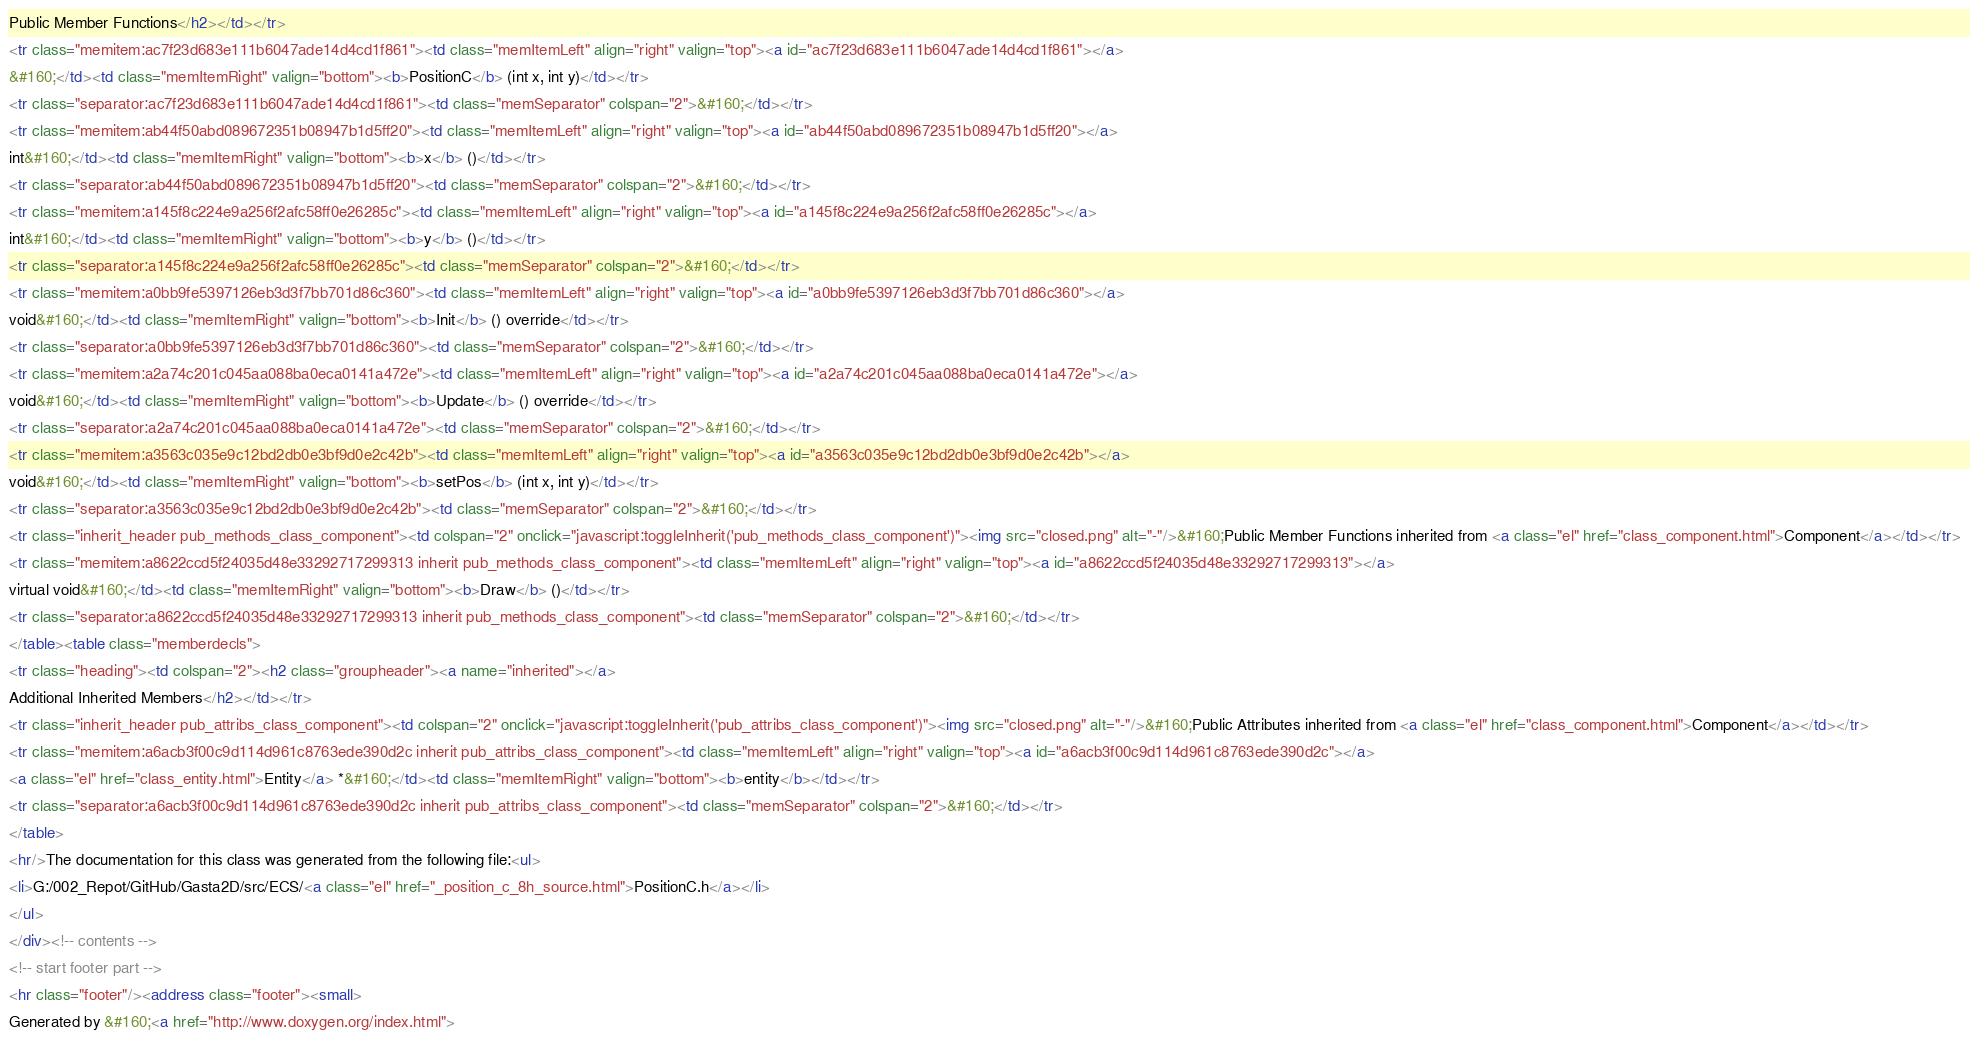Convert code to text. <code><loc_0><loc_0><loc_500><loc_500><_HTML_>Public Member Functions</h2></td></tr>
<tr class="memitem:ac7f23d683e111b6047ade14d4cd1f861"><td class="memItemLeft" align="right" valign="top"><a id="ac7f23d683e111b6047ade14d4cd1f861"></a>
&#160;</td><td class="memItemRight" valign="bottom"><b>PositionC</b> (int x, int y)</td></tr>
<tr class="separator:ac7f23d683e111b6047ade14d4cd1f861"><td class="memSeparator" colspan="2">&#160;</td></tr>
<tr class="memitem:ab44f50abd089672351b08947b1d5ff20"><td class="memItemLeft" align="right" valign="top"><a id="ab44f50abd089672351b08947b1d5ff20"></a>
int&#160;</td><td class="memItemRight" valign="bottom"><b>x</b> ()</td></tr>
<tr class="separator:ab44f50abd089672351b08947b1d5ff20"><td class="memSeparator" colspan="2">&#160;</td></tr>
<tr class="memitem:a145f8c224e9a256f2afc58ff0e26285c"><td class="memItemLeft" align="right" valign="top"><a id="a145f8c224e9a256f2afc58ff0e26285c"></a>
int&#160;</td><td class="memItemRight" valign="bottom"><b>y</b> ()</td></tr>
<tr class="separator:a145f8c224e9a256f2afc58ff0e26285c"><td class="memSeparator" colspan="2">&#160;</td></tr>
<tr class="memitem:a0bb9fe5397126eb3d3f7bb701d86c360"><td class="memItemLeft" align="right" valign="top"><a id="a0bb9fe5397126eb3d3f7bb701d86c360"></a>
void&#160;</td><td class="memItemRight" valign="bottom"><b>Init</b> () override</td></tr>
<tr class="separator:a0bb9fe5397126eb3d3f7bb701d86c360"><td class="memSeparator" colspan="2">&#160;</td></tr>
<tr class="memitem:a2a74c201c045aa088ba0eca0141a472e"><td class="memItemLeft" align="right" valign="top"><a id="a2a74c201c045aa088ba0eca0141a472e"></a>
void&#160;</td><td class="memItemRight" valign="bottom"><b>Update</b> () override</td></tr>
<tr class="separator:a2a74c201c045aa088ba0eca0141a472e"><td class="memSeparator" colspan="2">&#160;</td></tr>
<tr class="memitem:a3563c035e9c12bd2db0e3bf9d0e2c42b"><td class="memItemLeft" align="right" valign="top"><a id="a3563c035e9c12bd2db0e3bf9d0e2c42b"></a>
void&#160;</td><td class="memItemRight" valign="bottom"><b>setPos</b> (int x, int y)</td></tr>
<tr class="separator:a3563c035e9c12bd2db0e3bf9d0e2c42b"><td class="memSeparator" colspan="2">&#160;</td></tr>
<tr class="inherit_header pub_methods_class_component"><td colspan="2" onclick="javascript:toggleInherit('pub_methods_class_component')"><img src="closed.png" alt="-"/>&#160;Public Member Functions inherited from <a class="el" href="class_component.html">Component</a></td></tr>
<tr class="memitem:a8622ccd5f24035d48e33292717299313 inherit pub_methods_class_component"><td class="memItemLeft" align="right" valign="top"><a id="a8622ccd5f24035d48e33292717299313"></a>
virtual void&#160;</td><td class="memItemRight" valign="bottom"><b>Draw</b> ()</td></tr>
<tr class="separator:a8622ccd5f24035d48e33292717299313 inherit pub_methods_class_component"><td class="memSeparator" colspan="2">&#160;</td></tr>
</table><table class="memberdecls">
<tr class="heading"><td colspan="2"><h2 class="groupheader"><a name="inherited"></a>
Additional Inherited Members</h2></td></tr>
<tr class="inherit_header pub_attribs_class_component"><td colspan="2" onclick="javascript:toggleInherit('pub_attribs_class_component')"><img src="closed.png" alt="-"/>&#160;Public Attributes inherited from <a class="el" href="class_component.html">Component</a></td></tr>
<tr class="memitem:a6acb3f00c9d114d961c8763ede390d2c inherit pub_attribs_class_component"><td class="memItemLeft" align="right" valign="top"><a id="a6acb3f00c9d114d961c8763ede390d2c"></a>
<a class="el" href="class_entity.html">Entity</a> *&#160;</td><td class="memItemRight" valign="bottom"><b>entity</b></td></tr>
<tr class="separator:a6acb3f00c9d114d961c8763ede390d2c inherit pub_attribs_class_component"><td class="memSeparator" colspan="2">&#160;</td></tr>
</table>
<hr/>The documentation for this class was generated from the following file:<ul>
<li>G:/002_Repot/GitHub/Gasta2D/src/ECS/<a class="el" href="_position_c_8h_source.html">PositionC.h</a></li>
</ul>
</div><!-- contents -->
<!-- start footer part -->
<hr class="footer"/><address class="footer"><small>
Generated by &#160;<a href="http://www.doxygen.org/index.html"></code> 